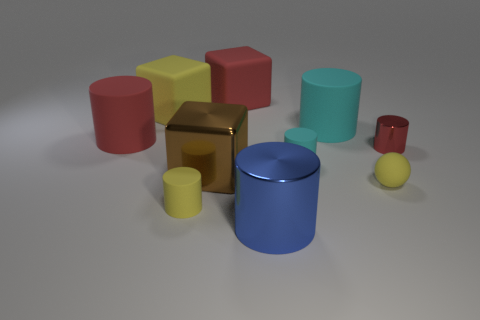How does the size of the blue cylinder compare to the other objects? The blue cylinder in the image is of medium size when compared to the other objects. It's taller than most other items such as the small spheres and cylinders but shorter than the large red matte cylinder. Its diameter is wider than the small cylinders but appears narrower than the yellow and red cubes. And what can you say about the relative position of this blue cylinder? The blue cylinder is located towards the foreground of the image, slightly off the center to the left. It is positioned in front of the tall red cylinder and to the left of the shiny small sphere, creating a visually appealing composition with a balance of color and form. 